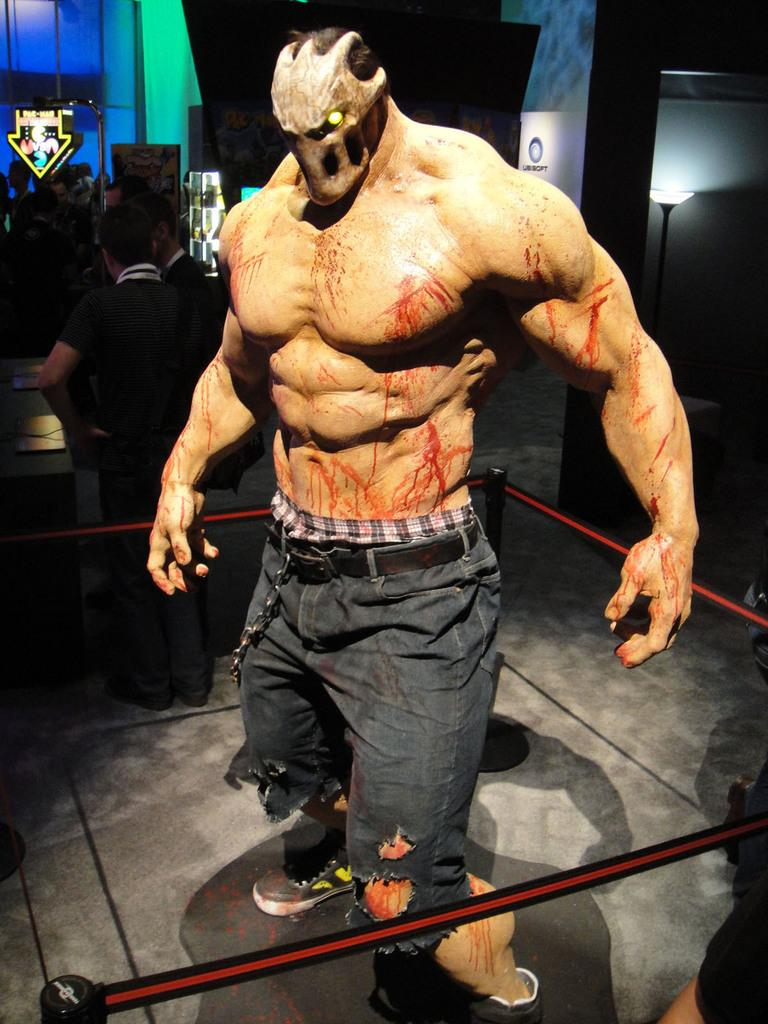What is the main subject of the image? The main subject of the image is a group of people. What can be seen in the middle of the image? There is a statue in the middle of the image. What is visible in the background of the image? There are lights visible in the background of the image. What type of fog can be seen surrounding the volleyball in the image? There is no volleyball present in the image, and therefore no fog surrounding it. 